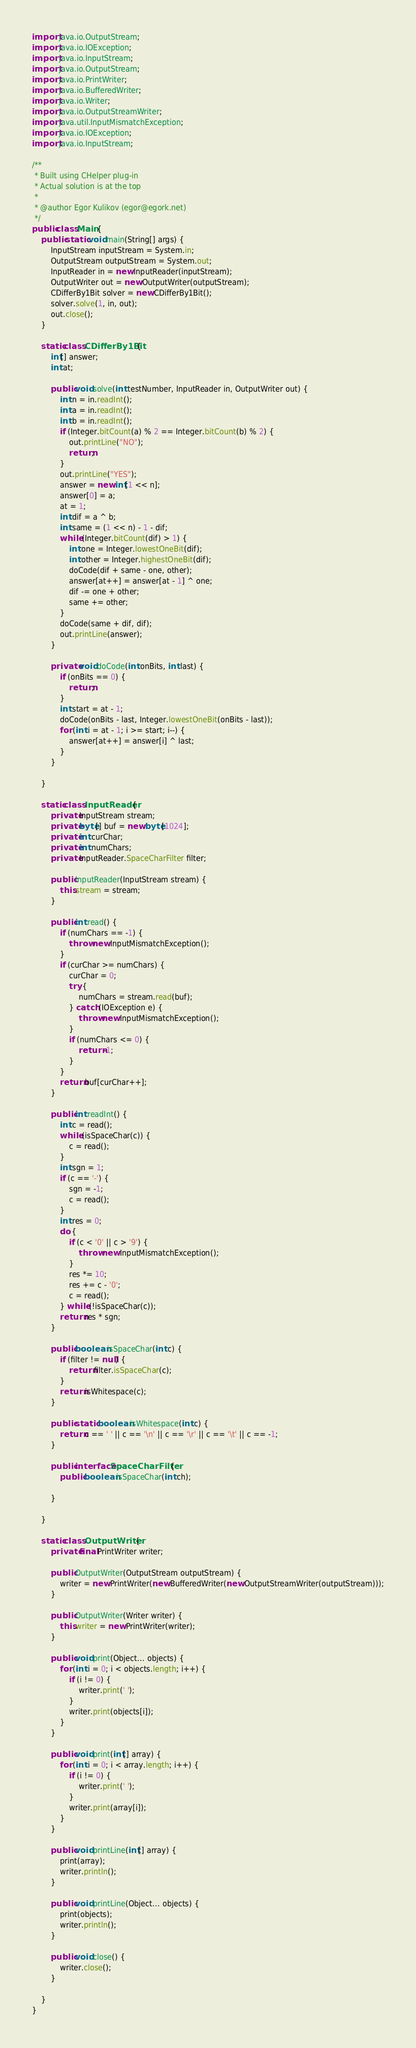Convert code to text. <code><loc_0><loc_0><loc_500><loc_500><_Java_>import java.io.OutputStream;
import java.io.IOException;
import java.io.InputStream;
import java.io.OutputStream;
import java.io.PrintWriter;
import java.io.BufferedWriter;
import java.io.Writer;
import java.io.OutputStreamWriter;
import java.util.InputMismatchException;
import java.io.IOException;
import java.io.InputStream;

/**
 * Built using CHelper plug-in
 * Actual solution is at the top
 *
 * @author Egor Kulikov (egor@egork.net)
 */
public class Main {
    public static void main(String[] args) {
        InputStream inputStream = System.in;
        OutputStream outputStream = System.out;
        InputReader in = new InputReader(inputStream);
        OutputWriter out = new OutputWriter(outputStream);
        CDifferBy1Bit solver = new CDifferBy1Bit();
        solver.solve(1, in, out);
        out.close();
    }

    static class CDifferBy1Bit {
        int[] answer;
        int at;

        public void solve(int testNumber, InputReader in, OutputWriter out) {
            int n = in.readInt();
            int a = in.readInt();
            int b = in.readInt();
            if (Integer.bitCount(a) % 2 == Integer.bitCount(b) % 2) {
                out.printLine("NO");
                return;
            }
            out.printLine("YES");
            answer = new int[1 << n];
            answer[0] = a;
            at = 1;
            int dif = a ^ b;
            int same = (1 << n) - 1 - dif;
            while (Integer.bitCount(dif) > 1) {
                int one = Integer.lowestOneBit(dif);
                int other = Integer.highestOneBit(dif);
                doCode(dif + same - one, other);
                answer[at++] = answer[at - 1] ^ one;
                dif -= one + other;
                same += other;
            }
            doCode(same + dif, dif);
            out.printLine(answer);
        }

        private void doCode(int onBits, int last) {
            if (onBits == 0) {
                return;
            }
            int start = at - 1;
            doCode(onBits - last, Integer.lowestOneBit(onBits - last));
            for (int i = at - 1; i >= start; i--) {
                answer[at++] = answer[i] ^ last;
            }
        }

    }

    static class InputReader {
        private InputStream stream;
        private byte[] buf = new byte[1024];
        private int curChar;
        private int numChars;
        private InputReader.SpaceCharFilter filter;

        public InputReader(InputStream stream) {
            this.stream = stream;
        }

        public int read() {
            if (numChars == -1) {
                throw new InputMismatchException();
            }
            if (curChar >= numChars) {
                curChar = 0;
                try {
                    numChars = stream.read(buf);
                } catch (IOException e) {
                    throw new InputMismatchException();
                }
                if (numChars <= 0) {
                    return -1;
                }
            }
            return buf[curChar++];
        }

        public int readInt() {
            int c = read();
            while (isSpaceChar(c)) {
                c = read();
            }
            int sgn = 1;
            if (c == '-') {
                sgn = -1;
                c = read();
            }
            int res = 0;
            do {
                if (c < '0' || c > '9') {
                    throw new InputMismatchException();
                }
                res *= 10;
                res += c - '0';
                c = read();
            } while (!isSpaceChar(c));
            return res * sgn;
        }

        public boolean isSpaceChar(int c) {
            if (filter != null) {
                return filter.isSpaceChar(c);
            }
            return isWhitespace(c);
        }

        public static boolean isWhitespace(int c) {
            return c == ' ' || c == '\n' || c == '\r' || c == '\t' || c == -1;
        }

        public interface SpaceCharFilter {
            public boolean isSpaceChar(int ch);

        }

    }

    static class OutputWriter {
        private final PrintWriter writer;

        public OutputWriter(OutputStream outputStream) {
            writer = new PrintWriter(new BufferedWriter(new OutputStreamWriter(outputStream)));
        }

        public OutputWriter(Writer writer) {
            this.writer = new PrintWriter(writer);
        }

        public void print(Object... objects) {
            for (int i = 0; i < objects.length; i++) {
                if (i != 0) {
                    writer.print(' ');
                }
                writer.print(objects[i]);
            }
        }

        public void print(int[] array) {
            for (int i = 0; i < array.length; i++) {
                if (i != 0) {
                    writer.print(' ');
                }
                writer.print(array[i]);
            }
        }

        public void printLine(int[] array) {
            print(array);
            writer.println();
        }

        public void printLine(Object... objects) {
            print(objects);
            writer.println();
        }

        public void close() {
            writer.close();
        }

    }
}

</code> 